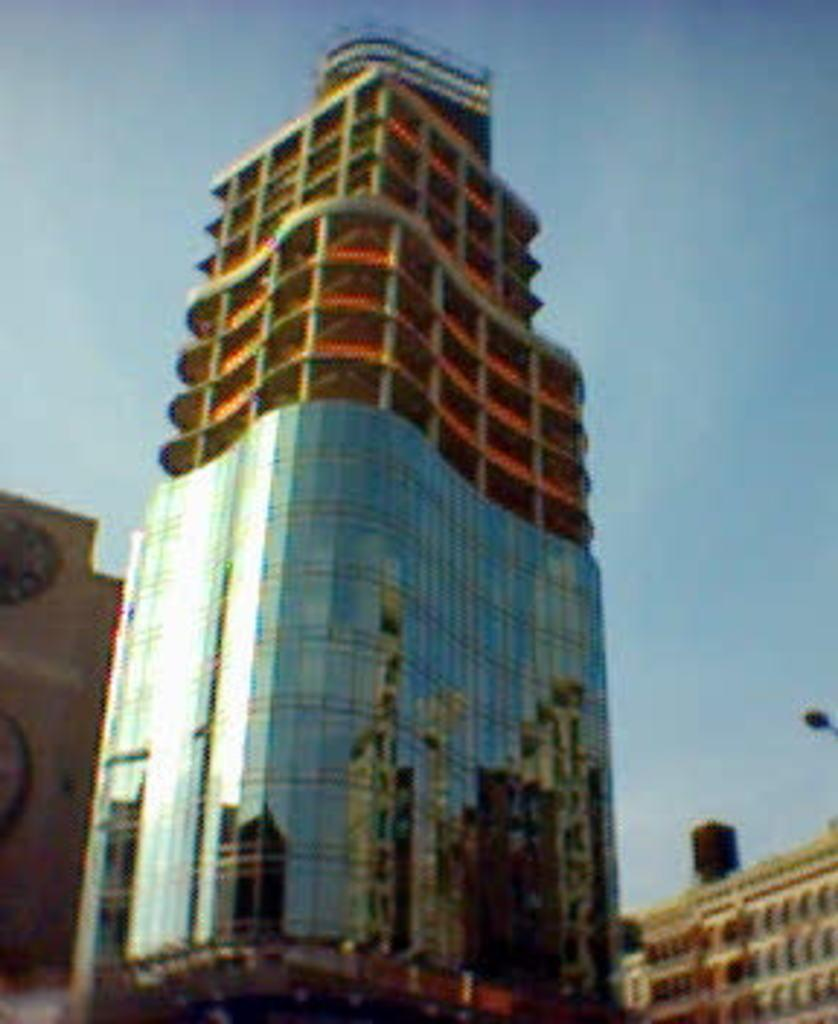What type of structure is present in the image? There is a building in the image. What can be seen in the background of the image? The sky is visible in the background of the image. What type of game is being played in the image? There is no game present in the image; it only features a building and the sky. What color is the thread used to decorate the building in the image? There is no thread or decoration mentioned in the image; it only features a building and the sky. 